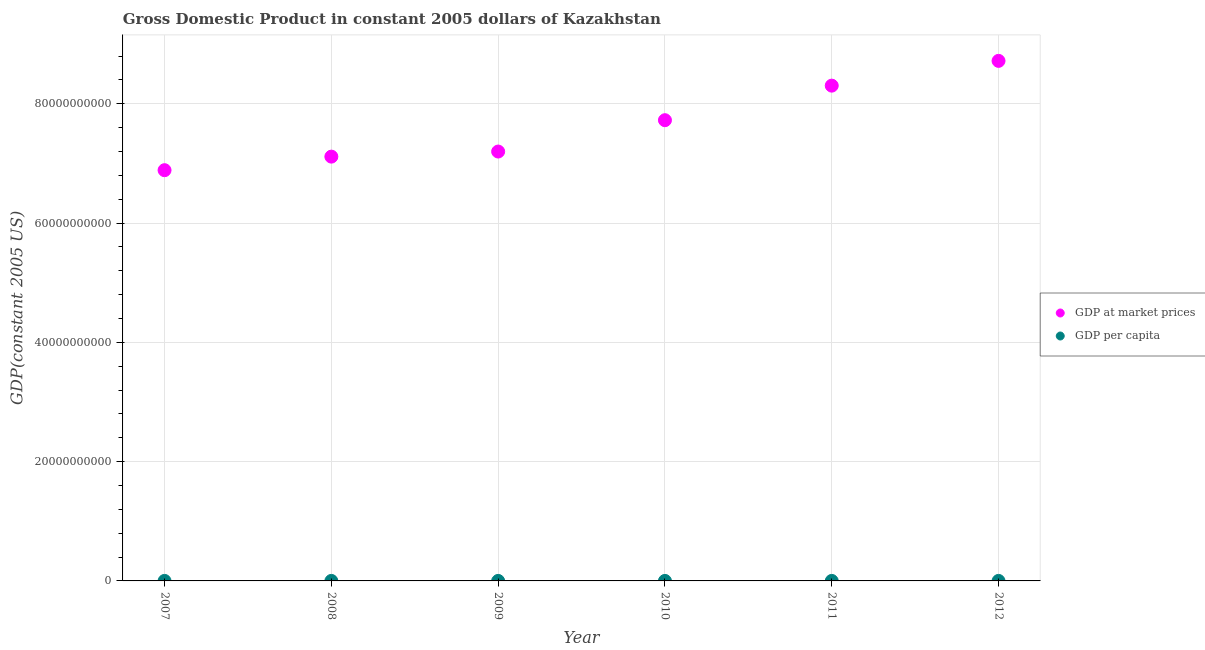How many different coloured dotlines are there?
Provide a succinct answer. 2. Is the number of dotlines equal to the number of legend labels?
Keep it short and to the point. Yes. What is the gdp per capita in 2011?
Make the answer very short. 5015.45. Across all years, what is the maximum gdp per capita?
Offer a terse response. 5192.57. Across all years, what is the minimum gdp at market prices?
Your response must be concise. 6.89e+1. In which year was the gdp per capita minimum?
Make the answer very short. 2007. What is the total gdp at market prices in the graph?
Ensure brevity in your answer.  4.59e+11. What is the difference between the gdp per capita in 2009 and that in 2010?
Your response must be concise. -259.25. What is the difference between the gdp per capita in 2007 and the gdp at market prices in 2009?
Keep it short and to the point. -7.20e+1. What is the average gdp per capita per year?
Give a very brief answer. 4733.34. In the year 2008, what is the difference between the gdp per capita and gdp at market prices?
Your answer should be very brief. -7.11e+1. What is the ratio of the gdp per capita in 2007 to that in 2008?
Offer a very short reply. 0.98. What is the difference between the highest and the second highest gdp per capita?
Keep it short and to the point. 177.13. What is the difference between the highest and the lowest gdp per capita?
Provide a succinct answer. 745.2. In how many years, is the gdp per capita greater than the average gdp per capita taken over all years?
Provide a short and direct response. 2. Are the values on the major ticks of Y-axis written in scientific E-notation?
Your response must be concise. No. Does the graph contain grids?
Offer a very short reply. Yes. Where does the legend appear in the graph?
Your answer should be compact. Center right. How are the legend labels stacked?
Your answer should be very brief. Vertical. What is the title of the graph?
Your answer should be very brief. Gross Domestic Product in constant 2005 dollars of Kazakhstan. What is the label or title of the X-axis?
Your answer should be very brief. Year. What is the label or title of the Y-axis?
Ensure brevity in your answer.  GDP(constant 2005 US). What is the GDP(constant 2005 US) of GDP at market prices in 2007?
Offer a terse response. 6.89e+1. What is the GDP(constant 2005 US) in GDP per capita in 2007?
Offer a very short reply. 4447.37. What is the GDP(constant 2005 US) in GDP at market prices in 2008?
Your answer should be very brief. 7.11e+1. What is the GDP(constant 2005 US) of GDP per capita in 2008?
Ensure brevity in your answer.  4538.5. What is the GDP(constant 2005 US) of GDP at market prices in 2009?
Your answer should be very brief. 7.20e+1. What is the GDP(constant 2005 US) of GDP per capita in 2009?
Give a very brief answer. 4473.46. What is the GDP(constant 2005 US) in GDP at market prices in 2010?
Your answer should be very brief. 7.72e+1. What is the GDP(constant 2005 US) of GDP per capita in 2010?
Keep it short and to the point. 4732.71. What is the GDP(constant 2005 US) in GDP at market prices in 2011?
Provide a short and direct response. 8.30e+1. What is the GDP(constant 2005 US) of GDP per capita in 2011?
Give a very brief answer. 5015.45. What is the GDP(constant 2005 US) of GDP at market prices in 2012?
Offer a terse response. 8.72e+1. What is the GDP(constant 2005 US) in GDP per capita in 2012?
Ensure brevity in your answer.  5192.57. Across all years, what is the maximum GDP(constant 2005 US) of GDP at market prices?
Provide a short and direct response. 8.72e+1. Across all years, what is the maximum GDP(constant 2005 US) of GDP per capita?
Make the answer very short. 5192.57. Across all years, what is the minimum GDP(constant 2005 US) in GDP at market prices?
Keep it short and to the point. 6.89e+1. Across all years, what is the minimum GDP(constant 2005 US) of GDP per capita?
Provide a short and direct response. 4447.37. What is the total GDP(constant 2005 US) in GDP at market prices in the graph?
Your answer should be very brief. 4.59e+11. What is the total GDP(constant 2005 US) of GDP per capita in the graph?
Your answer should be very brief. 2.84e+04. What is the difference between the GDP(constant 2005 US) in GDP at market prices in 2007 and that in 2008?
Your response must be concise. -2.27e+09. What is the difference between the GDP(constant 2005 US) of GDP per capita in 2007 and that in 2008?
Your response must be concise. -91.13. What is the difference between the GDP(constant 2005 US) in GDP at market prices in 2007 and that in 2009?
Give a very brief answer. -3.13e+09. What is the difference between the GDP(constant 2005 US) of GDP per capita in 2007 and that in 2009?
Provide a succinct answer. -26.09. What is the difference between the GDP(constant 2005 US) in GDP at market prices in 2007 and that in 2010?
Your response must be concise. -8.38e+09. What is the difference between the GDP(constant 2005 US) in GDP per capita in 2007 and that in 2010?
Keep it short and to the point. -285.34. What is the difference between the GDP(constant 2005 US) in GDP at market prices in 2007 and that in 2011?
Provide a short and direct response. -1.42e+1. What is the difference between the GDP(constant 2005 US) of GDP per capita in 2007 and that in 2011?
Ensure brevity in your answer.  -568.08. What is the difference between the GDP(constant 2005 US) in GDP at market prices in 2007 and that in 2012?
Make the answer very short. -1.83e+1. What is the difference between the GDP(constant 2005 US) of GDP per capita in 2007 and that in 2012?
Keep it short and to the point. -745.2. What is the difference between the GDP(constant 2005 US) of GDP at market prices in 2008 and that in 2009?
Make the answer very short. -8.54e+08. What is the difference between the GDP(constant 2005 US) of GDP per capita in 2008 and that in 2009?
Give a very brief answer. 65.04. What is the difference between the GDP(constant 2005 US) in GDP at market prices in 2008 and that in 2010?
Your answer should be very brief. -6.11e+09. What is the difference between the GDP(constant 2005 US) of GDP per capita in 2008 and that in 2010?
Provide a short and direct response. -194.21. What is the difference between the GDP(constant 2005 US) of GDP at market prices in 2008 and that in 2011?
Offer a very short reply. -1.19e+1. What is the difference between the GDP(constant 2005 US) in GDP per capita in 2008 and that in 2011?
Keep it short and to the point. -476.95. What is the difference between the GDP(constant 2005 US) of GDP at market prices in 2008 and that in 2012?
Make the answer very short. -1.61e+1. What is the difference between the GDP(constant 2005 US) of GDP per capita in 2008 and that in 2012?
Offer a terse response. -654.07. What is the difference between the GDP(constant 2005 US) of GDP at market prices in 2009 and that in 2010?
Give a very brief answer. -5.26e+09. What is the difference between the GDP(constant 2005 US) in GDP per capita in 2009 and that in 2010?
Make the answer very short. -259.25. What is the difference between the GDP(constant 2005 US) of GDP at market prices in 2009 and that in 2011?
Your answer should be very brief. -1.10e+1. What is the difference between the GDP(constant 2005 US) of GDP per capita in 2009 and that in 2011?
Keep it short and to the point. -541.99. What is the difference between the GDP(constant 2005 US) in GDP at market prices in 2009 and that in 2012?
Provide a short and direct response. -1.52e+1. What is the difference between the GDP(constant 2005 US) in GDP per capita in 2009 and that in 2012?
Your response must be concise. -719.11. What is the difference between the GDP(constant 2005 US) in GDP at market prices in 2010 and that in 2011?
Give a very brief answer. -5.79e+09. What is the difference between the GDP(constant 2005 US) in GDP per capita in 2010 and that in 2011?
Keep it short and to the point. -282.73. What is the difference between the GDP(constant 2005 US) in GDP at market prices in 2010 and that in 2012?
Offer a terse response. -9.95e+09. What is the difference between the GDP(constant 2005 US) of GDP per capita in 2010 and that in 2012?
Provide a succinct answer. -459.86. What is the difference between the GDP(constant 2005 US) of GDP at market prices in 2011 and that in 2012?
Give a very brief answer. -4.15e+09. What is the difference between the GDP(constant 2005 US) in GDP per capita in 2011 and that in 2012?
Give a very brief answer. -177.13. What is the difference between the GDP(constant 2005 US) of GDP at market prices in 2007 and the GDP(constant 2005 US) of GDP per capita in 2008?
Offer a terse response. 6.89e+1. What is the difference between the GDP(constant 2005 US) in GDP at market prices in 2007 and the GDP(constant 2005 US) in GDP per capita in 2009?
Offer a very short reply. 6.89e+1. What is the difference between the GDP(constant 2005 US) of GDP at market prices in 2007 and the GDP(constant 2005 US) of GDP per capita in 2010?
Your response must be concise. 6.89e+1. What is the difference between the GDP(constant 2005 US) of GDP at market prices in 2007 and the GDP(constant 2005 US) of GDP per capita in 2011?
Make the answer very short. 6.89e+1. What is the difference between the GDP(constant 2005 US) of GDP at market prices in 2007 and the GDP(constant 2005 US) of GDP per capita in 2012?
Ensure brevity in your answer.  6.89e+1. What is the difference between the GDP(constant 2005 US) of GDP at market prices in 2008 and the GDP(constant 2005 US) of GDP per capita in 2009?
Give a very brief answer. 7.11e+1. What is the difference between the GDP(constant 2005 US) of GDP at market prices in 2008 and the GDP(constant 2005 US) of GDP per capita in 2010?
Your answer should be compact. 7.11e+1. What is the difference between the GDP(constant 2005 US) of GDP at market prices in 2008 and the GDP(constant 2005 US) of GDP per capita in 2011?
Ensure brevity in your answer.  7.11e+1. What is the difference between the GDP(constant 2005 US) of GDP at market prices in 2008 and the GDP(constant 2005 US) of GDP per capita in 2012?
Ensure brevity in your answer.  7.11e+1. What is the difference between the GDP(constant 2005 US) in GDP at market prices in 2009 and the GDP(constant 2005 US) in GDP per capita in 2010?
Give a very brief answer. 7.20e+1. What is the difference between the GDP(constant 2005 US) of GDP at market prices in 2009 and the GDP(constant 2005 US) of GDP per capita in 2011?
Offer a very short reply. 7.20e+1. What is the difference between the GDP(constant 2005 US) in GDP at market prices in 2009 and the GDP(constant 2005 US) in GDP per capita in 2012?
Give a very brief answer. 7.20e+1. What is the difference between the GDP(constant 2005 US) of GDP at market prices in 2010 and the GDP(constant 2005 US) of GDP per capita in 2011?
Your response must be concise. 7.72e+1. What is the difference between the GDP(constant 2005 US) of GDP at market prices in 2010 and the GDP(constant 2005 US) of GDP per capita in 2012?
Ensure brevity in your answer.  7.72e+1. What is the difference between the GDP(constant 2005 US) of GDP at market prices in 2011 and the GDP(constant 2005 US) of GDP per capita in 2012?
Your answer should be very brief. 8.30e+1. What is the average GDP(constant 2005 US) in GDP at market prices per year?
Give a very brief answer. 7.66e+1. What is the average GDP(constant 2005 US) of GDP per capita per year?
Ensure brevity in your answer.  4733.34. In the year 2007, what is the difference between the GDP(constant 2005 US) of GDP at market prices and GDP(constant 2005 US) of GDP per capita?
Provide a short and direct response. 6.89e+1. In the year 2008, what is the difference between the GDP(constant 2005 US) of GDP at market prices and GDP(constant 2005 US) of GDP per capita?
Keep it short and to the point. 7.11e+1. In the year 2009, what is the difference between the GDP(constant 2005 US) of GDP at market prices and GDP(constant 2005 US) of GDP per capita?
Provide a succinct answer. 7.20e+1. In the year 2010, what is the difference between the GDP(constant 2005 US) in GDP at market prices and GDP(constant 2005 US) in GDP per capita?
Your answer should be very brief. 7.72e+1. In the year 2011, what is the difference between the GDP(constant 2005 US) of GDP at market prices and GDP(constant 2005 US) of GDP per capita?
Offer a very short reply. 8.30e+1. In the year 2012, what is the difference between the GDP(constant 2005 US) of GDP at market prices and GDP(constant 2005 US) of GDP per capita?
Provide a succinct answer. 8.72e+1. What is the ratio of the GDP(constant 2005 US) in GDP at market prices in 2007 to that in 2008?
Offer a terse response. 0.97. What is the ratio of the GDP(constant 2005 US) in GDP per capita in 2007 to that in 2008?
Keep it short and to the point. 0.98. What is the ratio of the GDP(constant 2005 US) of GDP at market prices in 2007 to that in 2009?
Keep it short and to the point. 0.96. What is the ratio of the GDP(constant 2005 US) of GDP at market prices in 2007 to that in 2010?
Your response must be concise. 0.89. What is the ratio of the GDP(constant 2005 US) of GDP per capita in 2007 to that in 2010?
Offer a terse response. 0.94. What is the ratio of the GDP(constant 2005 US) in GDP at market prices in 2007 to that in 2011?
Ensure brevity in your answer.  0.83. What is the ratio of the GDP(constant 2005 US) of GDP per capita in 2007 to that in 2011?
Your answer should be very brief. 0.89. What is the ratio of the GDP(constant 2005 US) in GDP at market prices in 2007 to that in 2012?
Offer a terse response. 0.79. What is the ratio of the GDP(constant 2005 US) of GDP per capita in 2007 to that in 2012?
Make the answer very short. 0.86. What is the ratio of the GDP(constant 2005 US) in GDP per capita in 2008 to that in 2009?
Ensure brevity in your answer.  1.01. What is the ratio of the GDP(constant 2005 US) of GDP at market prices in 2008 to that in 2010?
Ensure brevity in your answer.  0.92. What is the ratio of the GDP(constant 2005 US) in GDP at market prices in 2008 to that in 2011?
Provide a succinct answer. 0.86. What is the ratio of the GDP(constant 2005 US) in GDP per capita in 2008 to that in 2011?
Your answer should be very brief. 0.9. What is the ratio of the GDP(constant 2005 US) of GDP at market prices in 2008 to that in 2012?
Your response must be concise. 0.82. What is the ratio of the GDP(constant 2005 US) of GDP per capita in 2008 to that in 2012?
Your answer should be compact. 0.87. What is the ratio of the GDP(constant 2005 US) in GDP at market prices in 2009 to that in 2010?
Provide a succinct answer. 0.93. What is the ratio of the GDP(constant 2005 US) in GDP per capita in 2009 to that in 2010?
Give a very brief answer. 0.95. What is the ratio of the GDP(constant 2005 US) in GDP at market prices in 2009 to that in 2011?
Your answer should be compact. 0.87. What is the ratio of the GDP(constant 2005 US) of GDP per capita in 2009 to that in 2011?
Make the answer very short. 0.89. What is the ratio of the GDP(constant 2005 US) in GDP at market prices in 2009 to that in 2012?
Your answer should be very brief. 0.83. What is the ratio of the GDP(constant 2005 US) in GDP per capita in 2009 to that in 2012?
Make the answer very short. 0.86. What is the ratio of the GDP(constant 2005 US) in GDP at market prices in 2010 to that in 2011?
Provide a succinct answer. 0.93. What is the ratio of the GDP(constant 2005 US) in GDP per capita in 2010 to that in 2011?
Offer a very short reply. 0.94. What is the ratio of the GDP(constant 2005 US) in GDP at market prices in 2010 to that in 2012?
Give a very brief answer. 0.89. What is the ratio of the GDP(constant 2005 US) in GDP per capita in 2010 to that in 2012?
Your answer should be very brief. 0.91. What is the ratio of the GDP(constant 2005 US) of GDP at market prices in 2011 to that in 2012?
Provide a succinct answer. 0.95. What is the ratio of the GDP(constant 2005 US) in GDP per capita in 2011 to that in 2012?
Give a very brief answer. 0.97. What is the difference between the highest and the second highest GDP(constant 2005 US) of GDP at market prices?
Give a very brief answer. 4.15e+09. What is the difference between the highest and the second highest GDP(constant 2005 US) of GDP per capita?
Give a very brief answer. 177.13. What is the difference between the highest and the lowest GDP(constant 2005 US) in GDP at market prices?
Make the answer very short. 1.83e+1. What is the difference between the highest and the lowest GDP(constant 2005 US) of GDP per capita?
Your answer should be very brief. 745.2. 